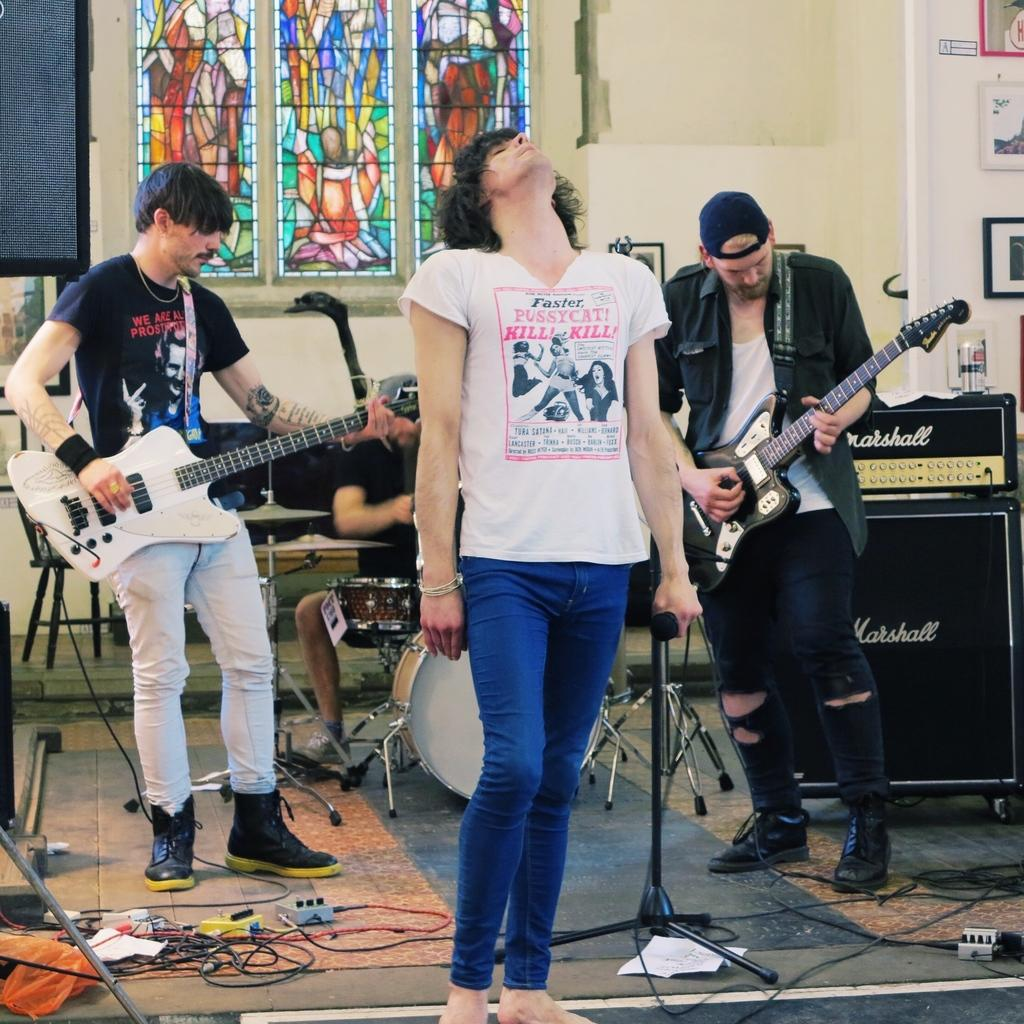What is the person in the image holding? The person in the image is holding a mic. What are the other people in the image doing? There are three people playing musical instruments in the image. What type of drug is the person holding in the image? There is no drug present in the image; the person is holding a mic. What is the distance between the person holding the mic and the person playing the farthest instrument in the image? The provided facts do not include information about the distance between the subjects in the image, so it cannot be determined. 